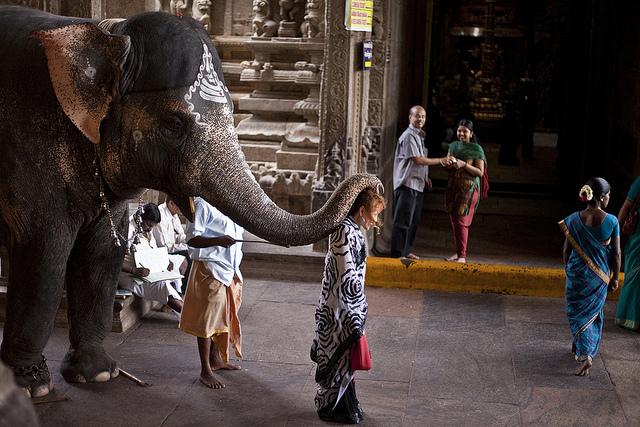Is the elephant brushing the woman's hair?
Be succinct. No. What color is the dress of the lady on the right?
Concise answer only. Blue. Did they ride on an elephant?
Be succinct. No. Is the elephant real?
Quick response, please. Yes. 